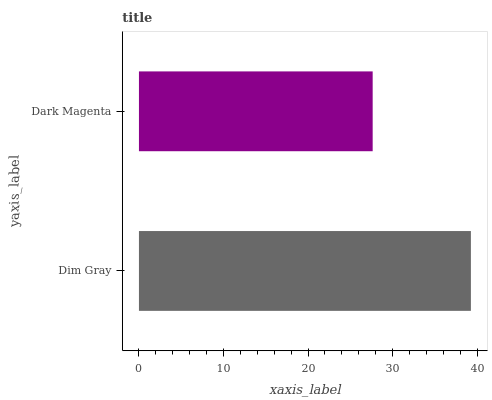Is Dark Magenta the minimum?
Answer yes or no. Yes. Is Dim Gray the maximum?
Answer yes or no. Yes. Is Dark Magenta the maximum?
Answer yes or no. No. Is Dim Gray greater than Dark Magenta?
Answer yes or no. Yes. Is Dark Magenta less than Dim Gray?
Answer yes or no. Yes. Is Dark Magenta greater than Dim Gray?
Answer yes or no. No. Is Dim Gray less than Dark Magenta?
Answer yes or no. No. Is Dim Gray the high median?
Answer yes or no. Yes. Is Dark Magenta the low median?
Answer yes or no. Yes. Is Dark Magenta the high median?
Answer yes or no. No. Is Dim Gray the low median?
Answer yes or no. No. 